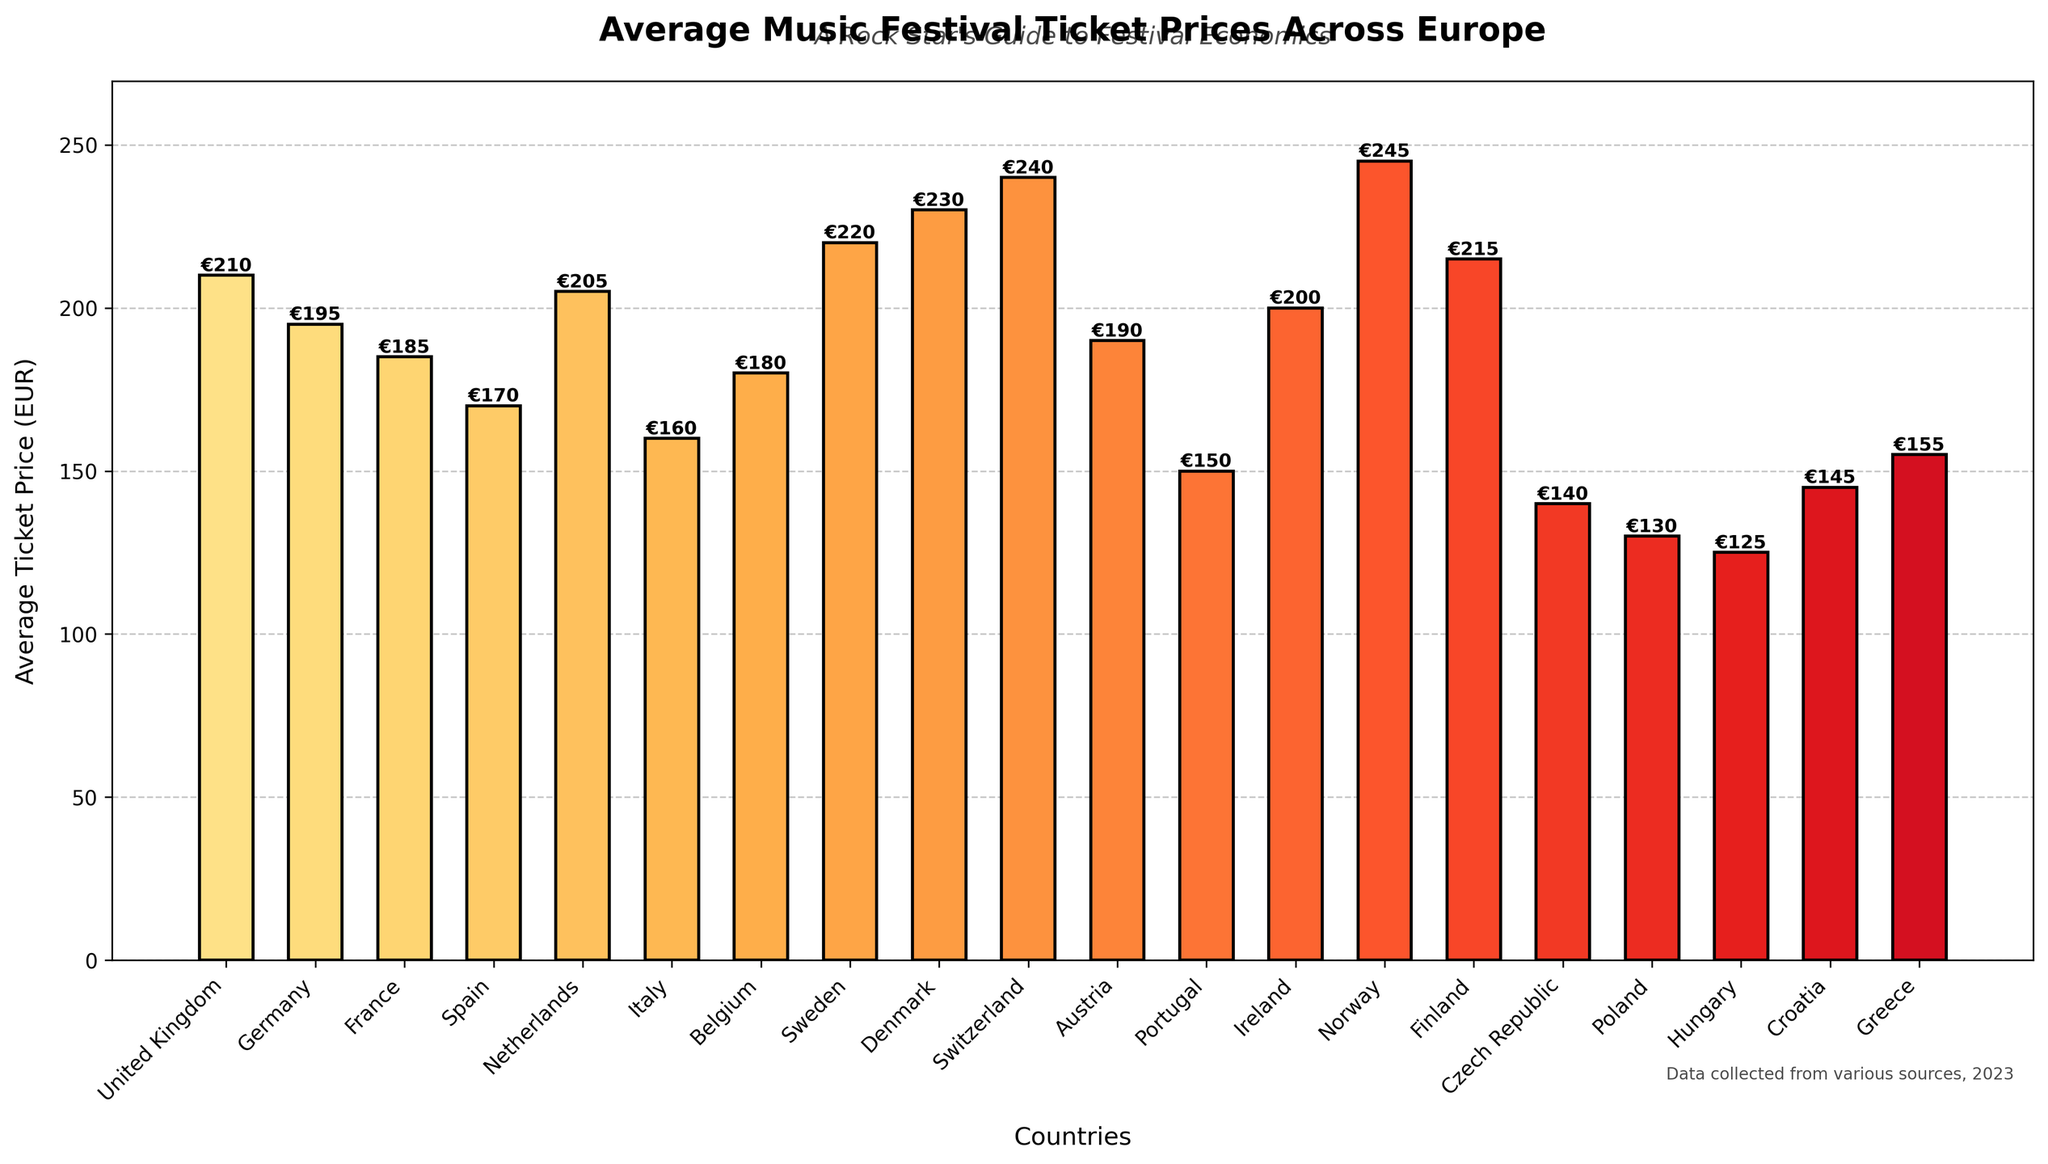Which country has the highest average music festival ticket price? By observing the heights of the bars in the chart, the country with the tallest bar represents the highest average ticket price. Switzerland has the tallest bar and is the most expensive.
Answer: Switzerland Which country has the lowest average music festival ticket price? By observing the heights of the bars in the chart, the country with the shortest bar represents the lowest average ticket price. Hungary has the shortest bar and is the cheapest.
Answer: Hungary What is the difference in average ticket prices between the United Kingdom and Netherlands? From the chart, the average ticket price in the United Kingdom is €210, and in the Netherlands, it is €205. The difference is calculated as €210 - €205.
Answer: €5 Which countries have average ticket prices greater than €200? By comparing the heights of the bars to the €200 mark on the y-axis, the countries with prices above €200 are the United Kingdom, Netherlands, Sweden, Denmark, Switzerland, Ireland, and Finland.
Answer: United Kingdom, Netherlands, Sweden, Denmark, Switzerland, Ireland, Finland Which countries have average ticket prices less than €150? Comparing the bars to the €150 mark on the y-axis, the countries with prices below €150 are Portugal, Czech Republic, Poland, Hungary, and Croatia.
Answer: Portugal, Czech Republic, Poland, Hungary, Croatia What is the difference in average ticket prices between Switzerland and Croatia? From the chart, Switzerland's price is €240, and Croatia's price is €145. The difference is calculated as €240 - €145.
Answer: €95 Find the median average ticket price of the countries listed. Arranging the ticket prices in ascending order: €125, €130, €140, €145, €150, €155, €160, €170, €180, €185, €190, €195, €200, €205, €210, €215, €220, €230, €240, €245. The median is the middle value, i.e., the 10th and 11th values: (€185 + €190) / 2.
Answer: €187.5 Which country has the closest average ticket price to the overall average price? Calculating the overall average: (Sum of all prices / Number of countries) = (210+195+185+170+205+160+180+220+230+240+190+150+200+245+215+140+130+125+145+155) / 20 = €183.5. The country closest to €183.5 is France (€185).
Answer: France What is the range of average ticket prices shown in the chart? The range is calculated as the difference between the highest and the lowest average ticket prices. Switzerland has the highest at €240 and Hungary the lowest at €125. Calculation: €240 - €125.
Answer: €115 How many countries have average ticket prices between €150 and €200? Observing the heights of the bars, the countries within this range are France, Spain, Italy, Belgium, Austria, and Ireland. Counting these bars gives the result.
Answer: 6 